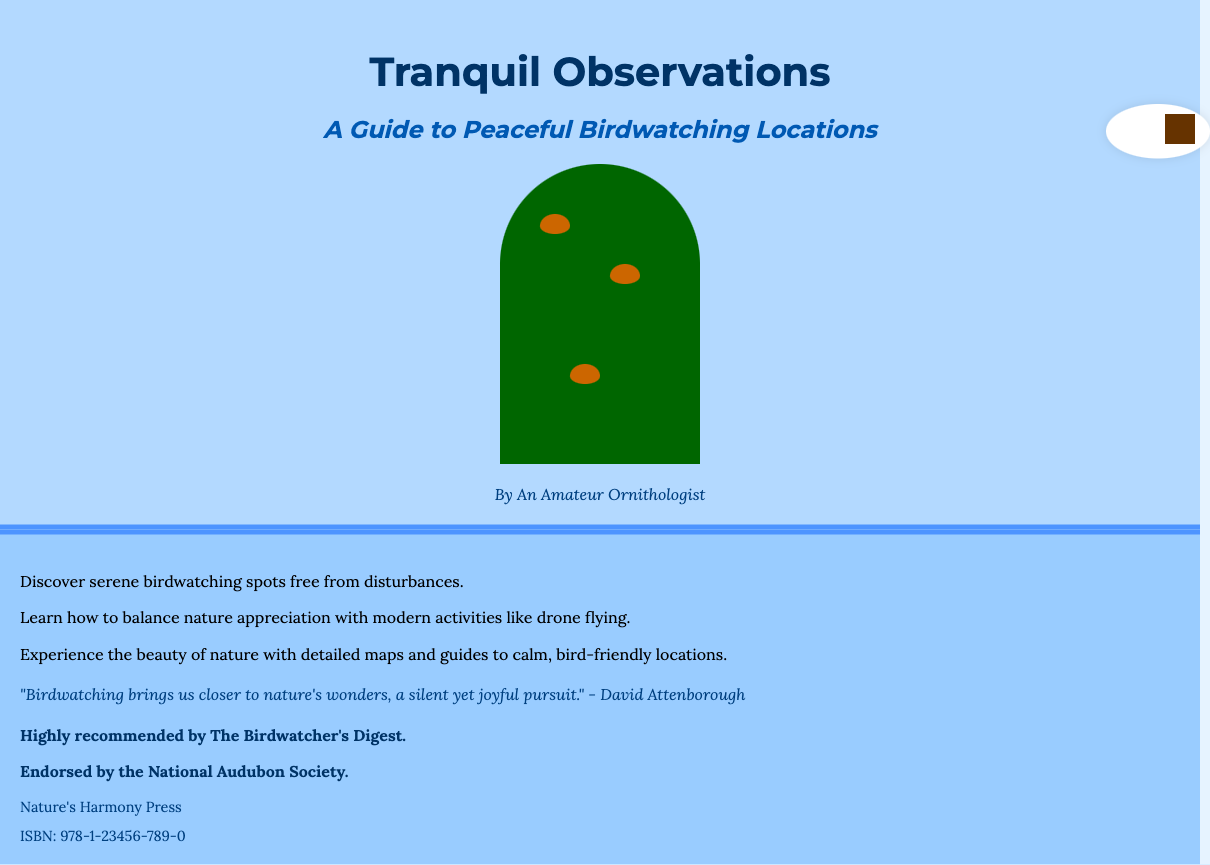What is the title of the book? The title is prominently displayed at the top of the front cover of the document.
Answer: Tranquil Observations Who is the author of the book? The author's name is mentioned at the bottom of the front cover.
Answer: An Amateur Ornithologist What does the book focus on in relation to birdwatching? The summary on the back cover specifies the main focus of the book.
Answer: Peaceful Birdwatching Locations Which society endorses the book? The endorsement section lists the organizations that recommend the book.
Answer: National Audubon Society How many birds are illustrated in the tree? The illustration shows a specific number of birds perched on the tree branches.
Answer: Three What type of background color is used for the book cover? The background color is clearly visible as described in the document.
Answer: Lightweight blue What information is included in the ISBN section? The ISBN section provides a unique identifier for the book, which includes numbers.
Answer: 978-1-23456-789-0 What is one of the topics discussed in the book regarding modern activities? The summary mentions a specific modern activity that relates to birdwatching.
Answer: Drone flying What kind of illustrations are featured on the cover? The document describes the design elements visible on the cover.
Answer: Softly perched birds on tree branches 